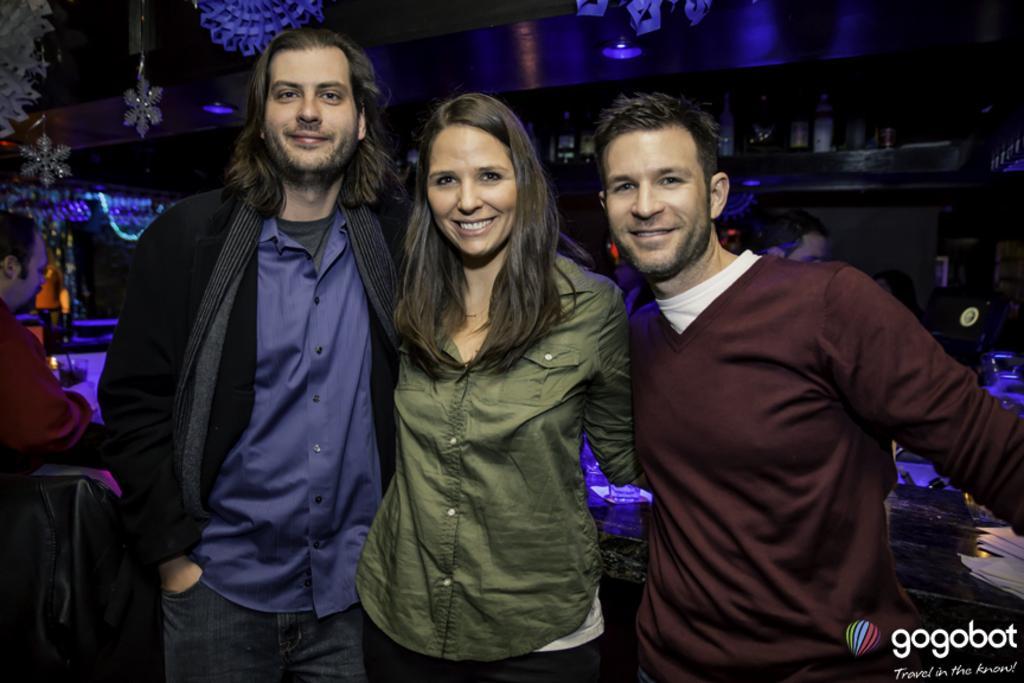Could you give a brief overview of what you see in this image? In this image we can see two men and one women are standing and smiling. One man is wearing a brown color t-shirt and the other man is wearing a blue color shirt with black jeans. The woman is wearing a green color shirt with black pant. Background of the image we can see the bottles are arranged in rack and people are there. We can see one more man on the left side of the image. There are some objects in the left top of the image. We can see one watermark in the right bottom of the image. 